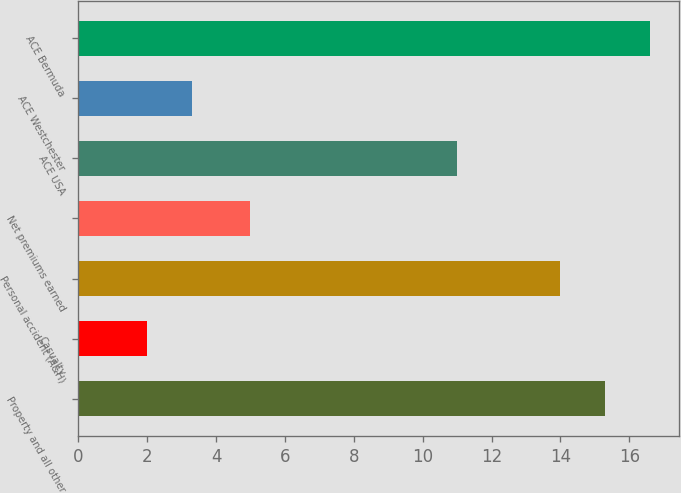Convert chart. <chart><loc_0><loc_0><loc_500><loc_500><bar_chart><fcel>Property and all other<fcel>Casualty<fcel>Personal accident (A&H)<fcel>Net premiums earned<fcel>ACE USA<fcel>ACE Westchester<fcel>ACE Bermuda<nl><fcel>15.3<fcel>2<fcel>14<fcel>5<fcel>11<fcel>3.3<fcel>16.6<nl></chart> 